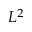<formula> <loc_0><loc_0><loc_500><loc_500>L ^ { 2 }</formula> 